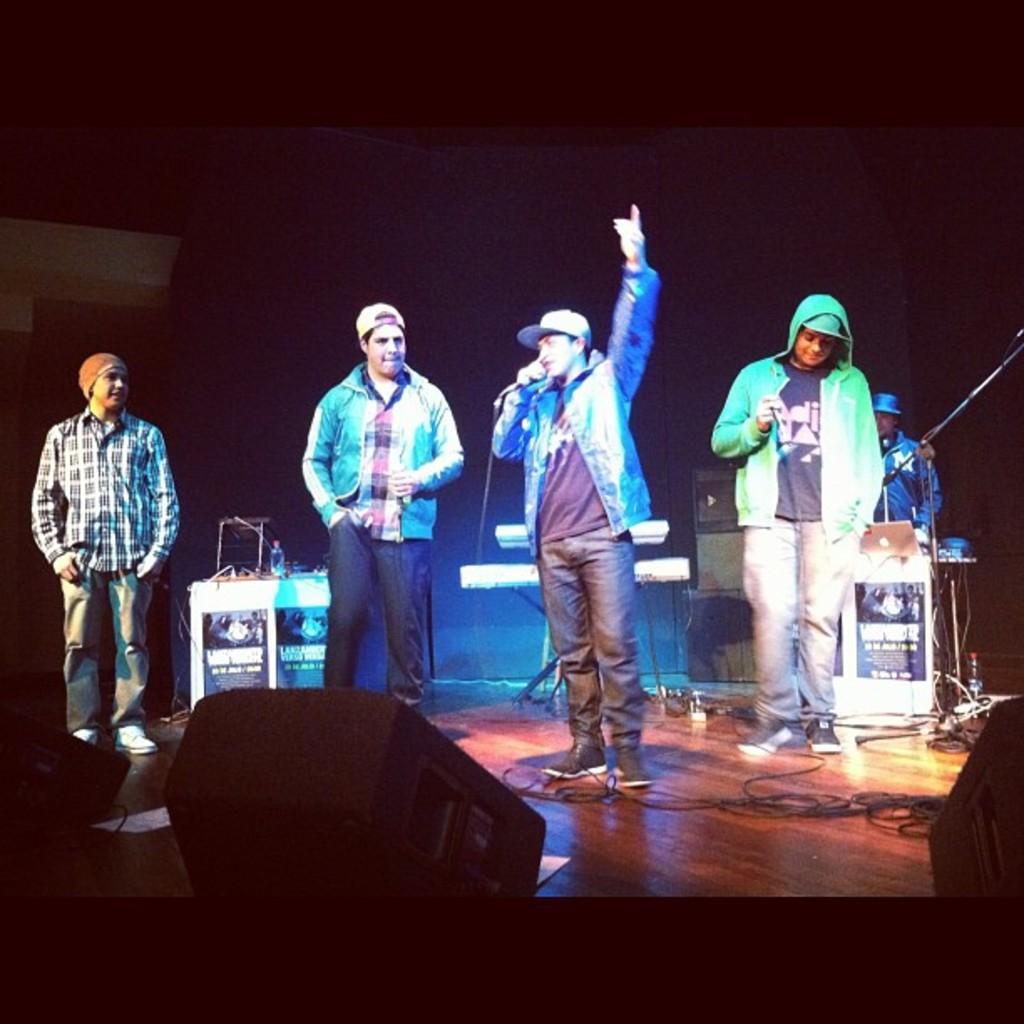In one or two sentences, can you explain what this image depicts? In this image there are people standing on the stage. Behind them there are musical instruments. In front of them there are some objects. There are tables. On top of it there are some objects. In the background of the image there is a wall. At the bottom of the image there are cables and papers on the floor. 